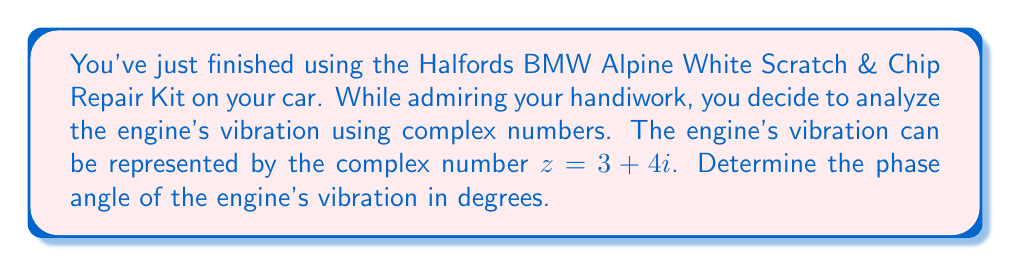Can you answer this question? To find the phase angle of the engine's vibration, we need to convert the complex number from rectangular form to polar form.

The complex number $z = 3 + 4i$ is in rectangular form $(a + bi)$.

1) First, calculate the magnitude (r) of the complex number:
   $$r = \sqrt{a^2 + b^2} = \sqrt{3^2 + 4^2} = \sqrt{9 + 16} = \sqrt{25} = 5$$

2) The phase angle $\theta$ can be calculated using the arctangent function:
   $$\theta = \arctan(\frac{b}{a}) = \arctan(\frac{4}{3})$$

3) Using a calculator or mathematical tables, we find:
   $$\arctan(\frac{4}{3}) \approx 0.9272952180 \text{ radians}$$

4) Convert radians to degrees:
   $$0.9272952180 \text{ radians} \times \frac{180°}{\pi} \approx 53.13010235°$$

Therefore, the phase angle of the engine's vibration is approximately 53.13°.
Answer: The phase angle of the engine's vibration is approximately 53.13°. 